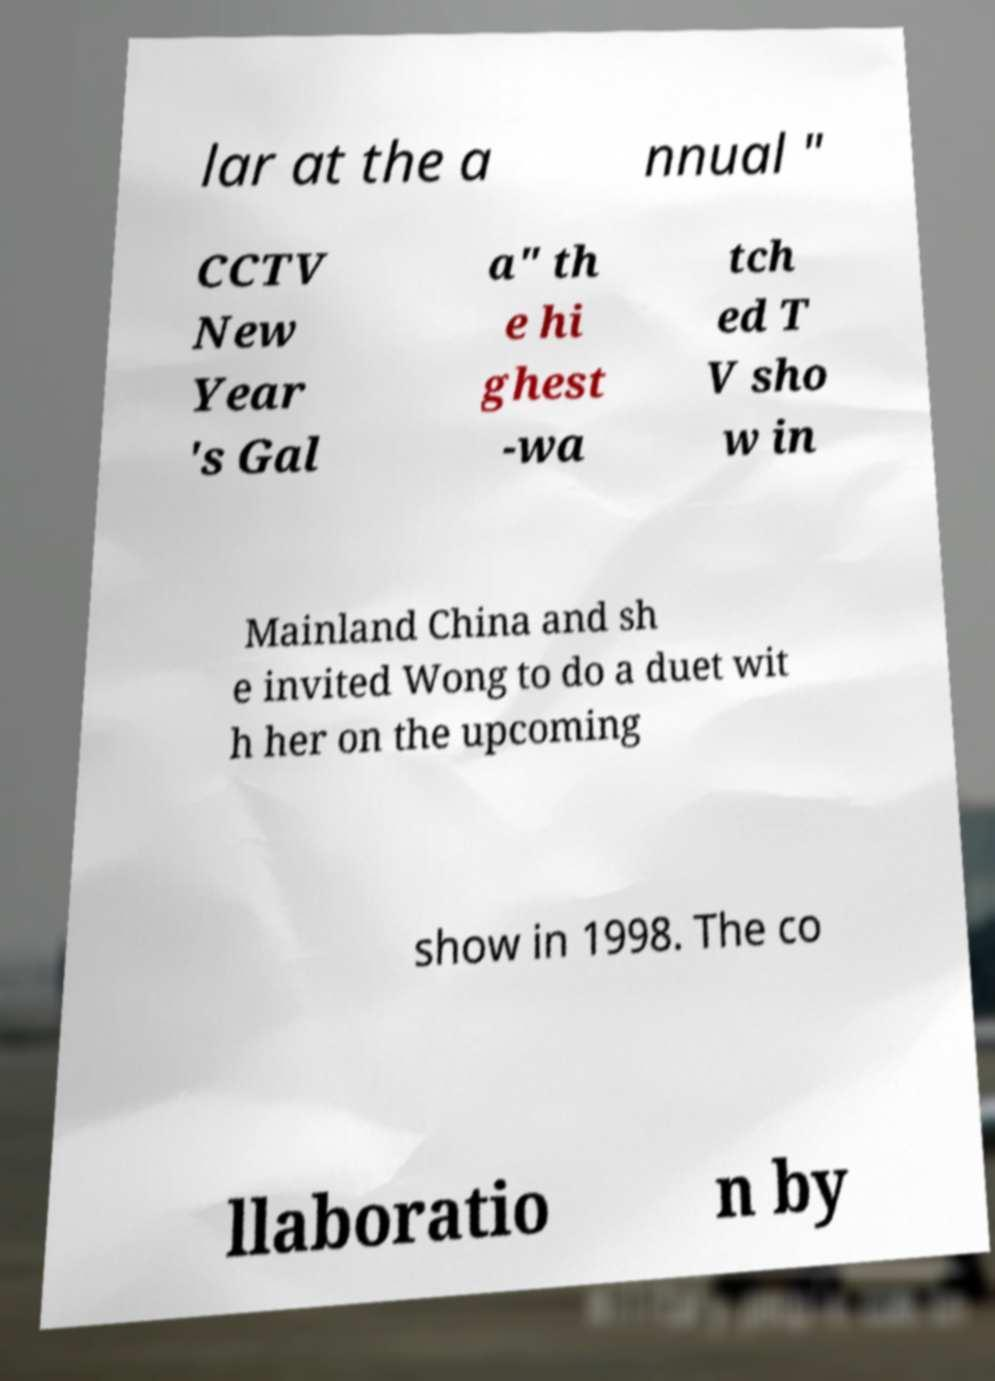I need the written content from this picture converted into text. Can you do that? lar at the a nnual " CCTV New Year 's Gal a" th e hi ghest -wa tch ed T V sho w in Mainland China and sh e invited Wong to do a duet wit h her on the upcoming show in 1998. The co llaboratio n by 